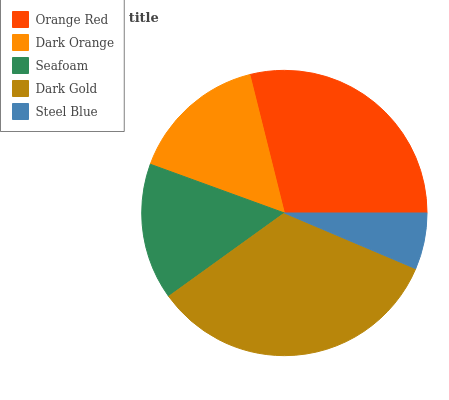Is Steel Blue the minimum?
Answer yes or no. Yes. Is Dark Gold the maximum?
Answer yes or no. Yes. Is Dark Orange the minimum?
Answer yes or no. No. Is Dark Orange the maximum?
Answer yes or no. No. Is Orange Red greater than Dark Orange?
Answer yes or no. Yes. Is Dark Orange less than Orange Red?
Answer yes or no. Yes. Is Dark Orange greater than Orange Red?
Answer yes or no. No. Is Orange Red less than Dark Orange?
Answer yes or no. No. Is Dark Orange the high median?
Answer yes or no. Yes. Is Dark Orange the low median?
Answer yes or no. Yes. Is Seafoam the high median?
Answer yes or no. No. Is Steel Blue the low median?
Answer yes or no. No. 